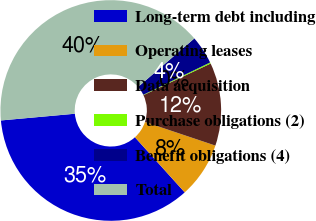<chart> <loc_0><loc_0><loc_500><loc_500><pie_chart><fcel>Long-term debt including<fcel>Operating leases<fcel>Data acquisition<fcel>Purchase obligations (2)<fcel>Benefit obligations (4)<fcel>Total<nl><fcel>35.25%<fcel>8.16%<fcel>12.15%<fcel>0.17%<fcel>4.16%<fcel>40.12%<nl></chart> 